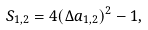<formula> <loc_0><loc_0><loc_500><loc_500>S _ { 1 , 2 } = 4 ( \Delta a _ { 1 , 2 } ) ^ { 2 } - 1 ,</formula> 